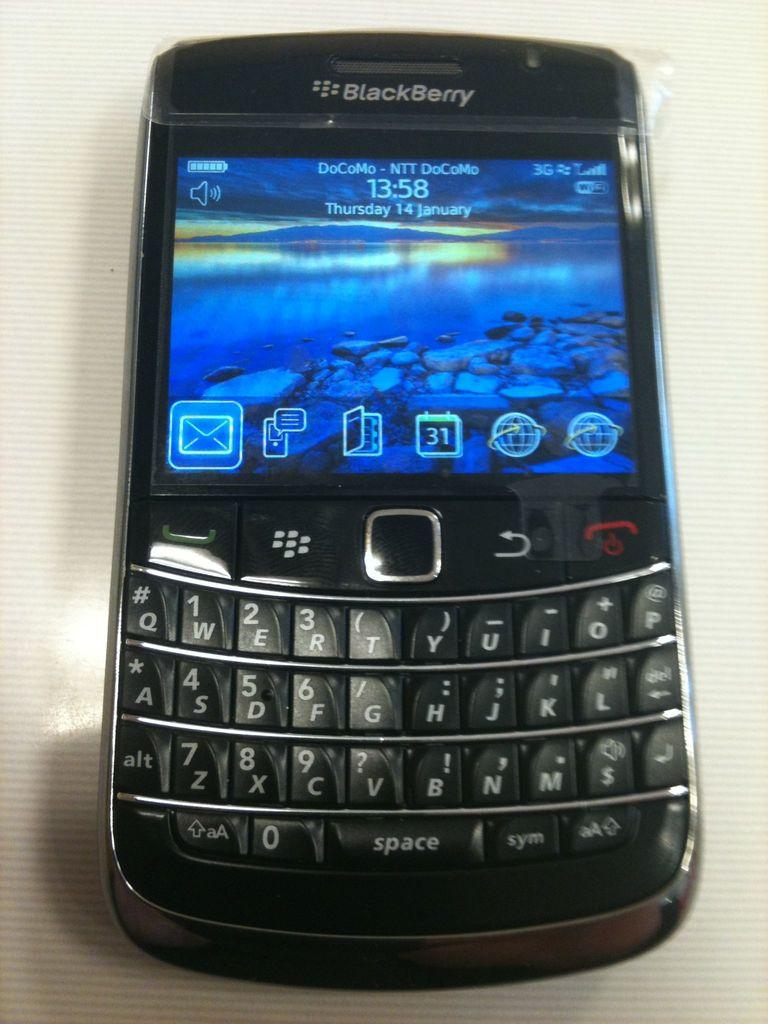<image>
Relay a brief, clear account of the picture shown. A DoCoMo BlackBerry displays a rocky river bank at dusk. 